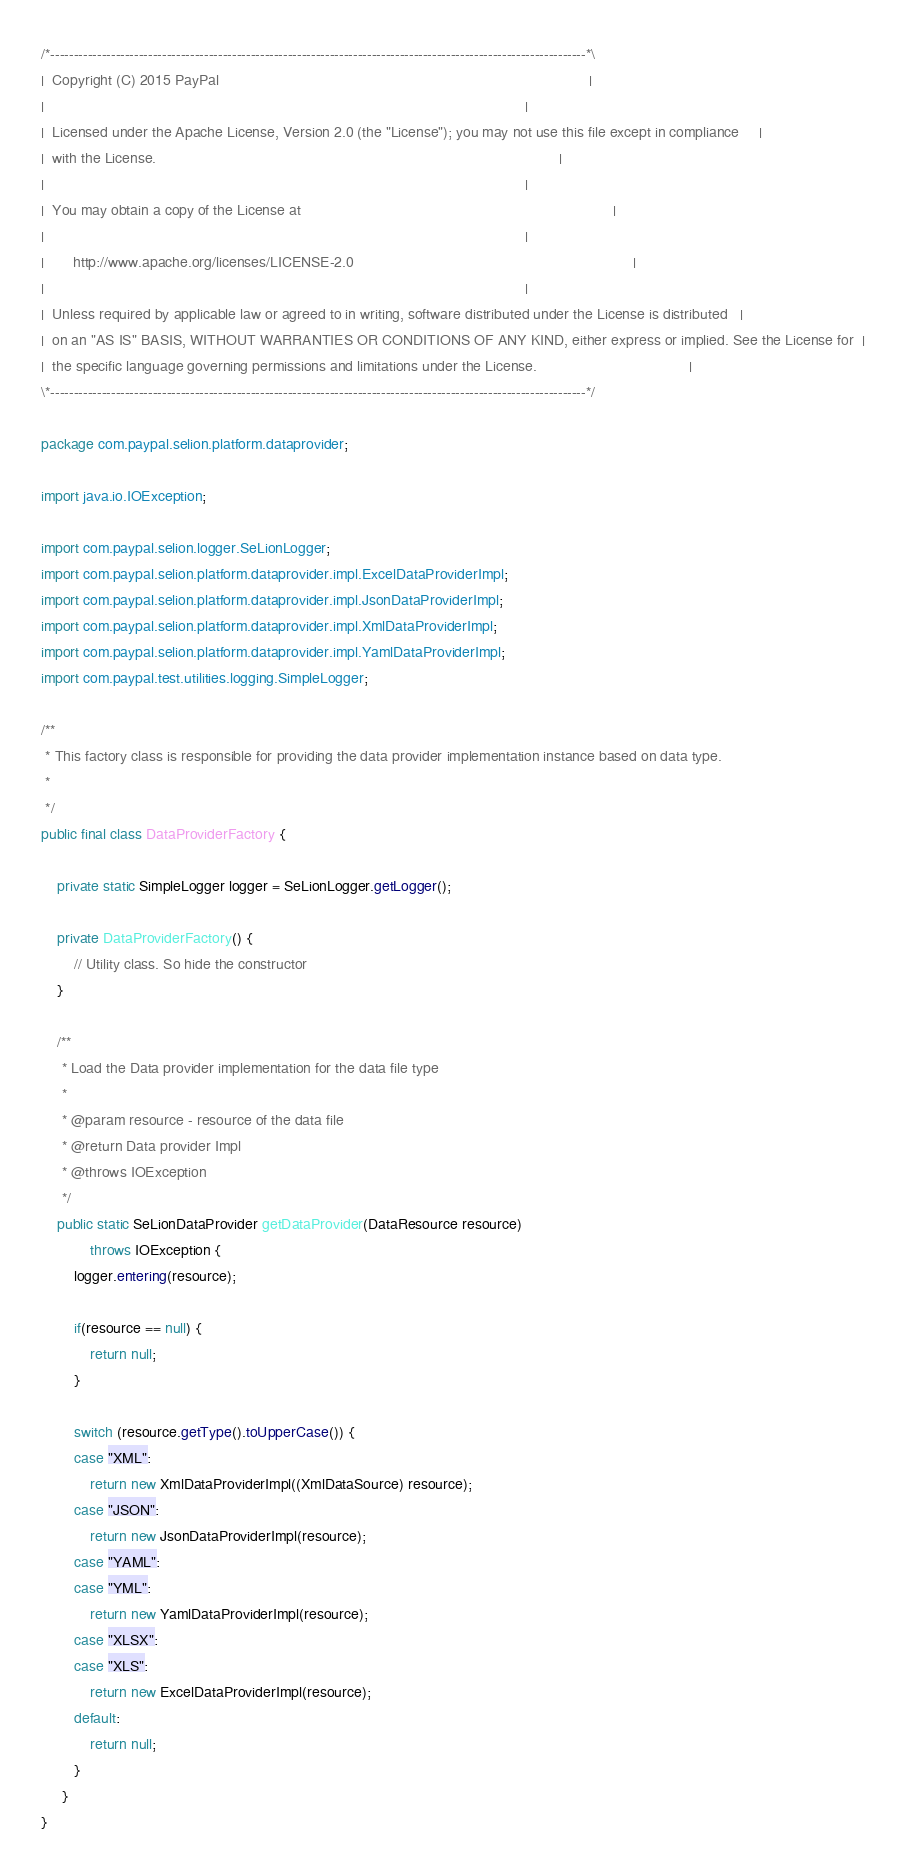Convert code to text. <code><loc_0><loc_0><loc_500><loc_500><_Java_>/*-------------------------------------------------------------------------------------------------------------------*\
|  Copyright (C) 2015 PayPal                                                                                          |
|                                                                                                                     |
|  Licensed under the Apache License, Version 2.0 (the "License"); you may not use this file except in compliance     |
|  with the License.                                                                                                  |
|                                                                                                                     |
|  You may obtain a copy of the License at                                                                            |
|                                                                                                                     |
|       http://www.apache.org/licenses/LICENSE-2.0                                                                    |
|                                                                                                                     |
|  Unless required by applicable law or agreed to in writing, software distributed under the License is distributed   |
|  on an "AS IS" BASIS, WITHOUT WARRANTIES OR CONDITIONS OF ANY KIND, either express or implied. See the License for  |
|  the specific language governing permissions and limitations under the License.                                     |
\*-------------------------------------------------------------------------------------------------------------------*/

package com.paypal.selion.platform.dataprovider;

import java.io.IOException;

import com.paypal.selion.logger.SeLionLogger;
import com.paypal.selion.platform.dataprovider.impl.ExcelDataProviderImpl;
import com.paypal.selion.platform.dataprovider.impl.JsonDataProviderImpl;
import com.paypal.selion.platform.dataprovider.impl.XmlDataProviderImpl;
import com.paypal.selion.platform.dataprovider.impl.YamlDataProviderImpl;
import com.paypal.test.utilities.logging.SimpleLogger;

/**
 * This factory class is responsible for providing the data provider implementation instance based on data type.
 *
 */
public final class DataProviderFactory {

    private static SimpleLogger logger = SeLionLogger.getLogger();

    private DataProviderFactory() {
        // Utility class. So hide the constructor
    }

    /**
     * Load the Data provider implementation for the data file type
     *
     * @param resource - resource of the data file
     * @return Data provider Impl
     * @throws IOException
     */
    public static SeLionDataProvider getDataProvider(DataResource resource)
            throws IOException {
        logger.entering(resource);

        if(resource == null) {
            return null;
        }

        switch (resource.getType().toUpperCase()) {
        case "XML":
            return new XmlDataProviderImpl((XmlDataSource) resource);
        case "JSON":
            return new JsonDataProviderImpl(resource);
        case "YAML":
        case "YML":
            return new YamlDataProviderImpl(resource);
        case "XLSX":
        case "XLS":
            return new ExcelDataProviderImpl(resource);
        default:
            return null;
        }
     }
}</code> 